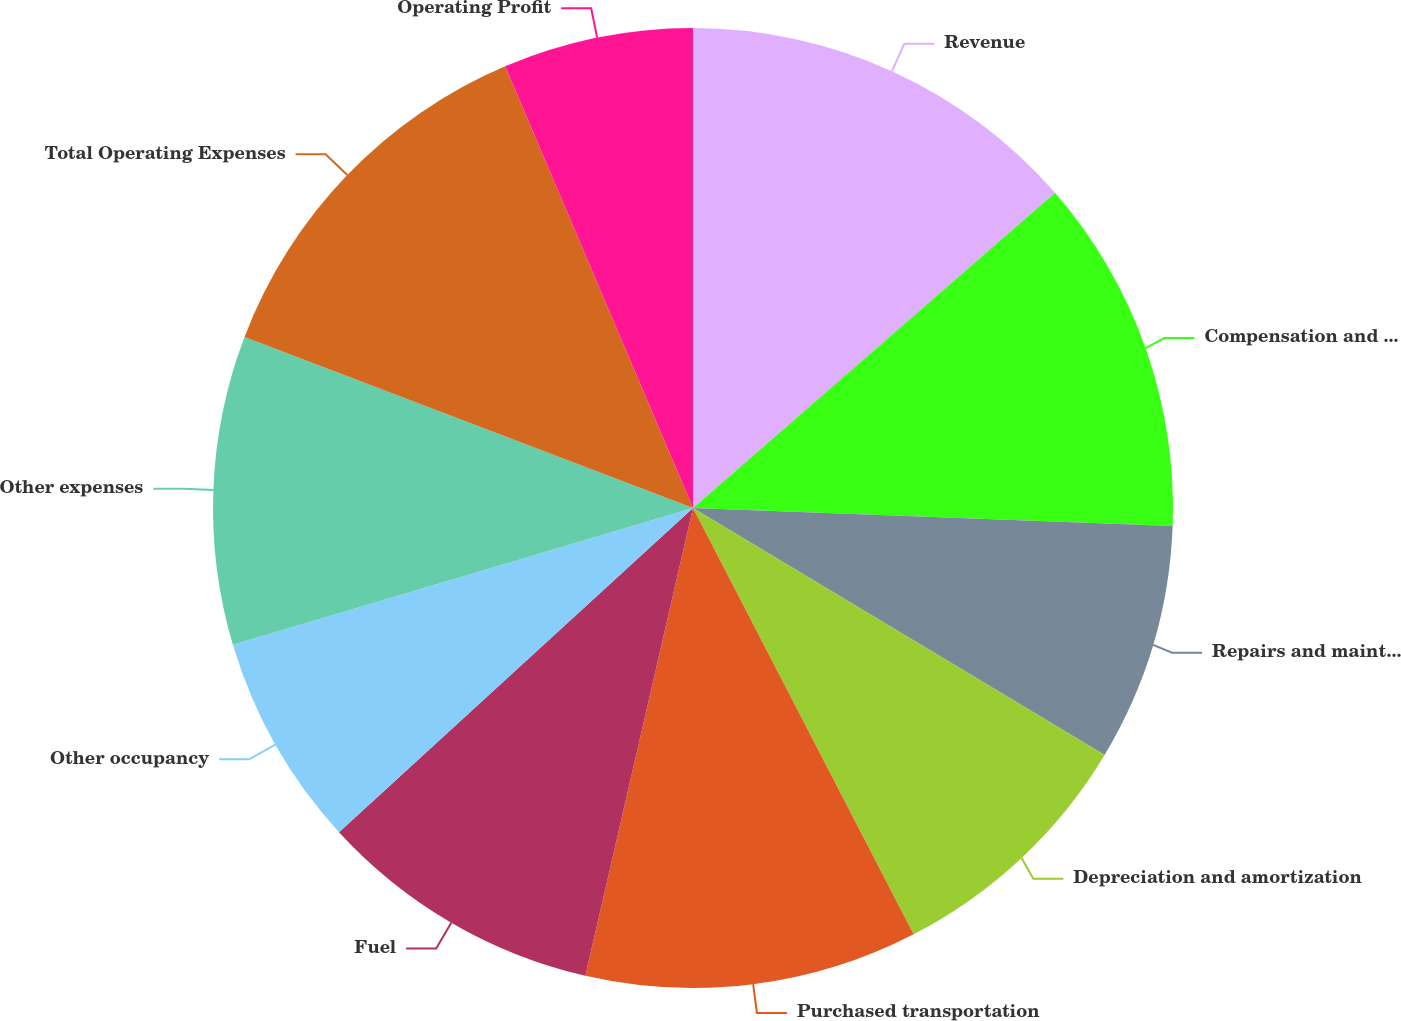Convert chart to OTSL. <chart><loc_0><loc_0><loc_500><loc_500><pie_chart><fcel>Revenue<fcel>Compensation and benefits<fcel>Repairs and maintenance<fcel>Depreciation and amortization<fcel>Purchased transportation<fcel>Fuel<fcel>Other occupancy<fcel>Other expenses<fcel>Total Operating Expenses<fcel>Operating Profit<nl><fcel>13.6%<fcel>12.0%<fcel>8.0%<fcel>8.8%<fcel>11.2%<fcel>9.6%<fcel>7.2%<fcel>10.4%<fcel>12.8%<fcel>6.4%<nl></chart> 